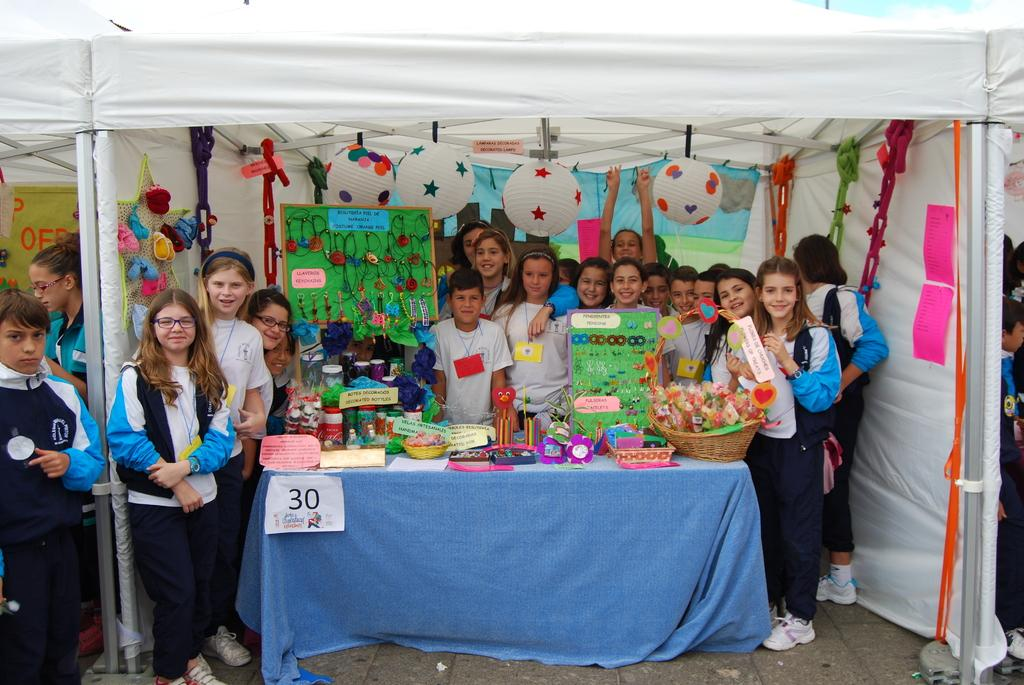How many people are in the image? There is a group of people standing in the image. What objects can be seen in the image besides the people? There is a basket, a toy, earrings, objects on a table, a boar's head, cloth, and paper in the image. Can you see any islands in the image? There are no islands present in the image. Are there any slaves depicted in the image? There is no reference to slavery or slaves in the image. 